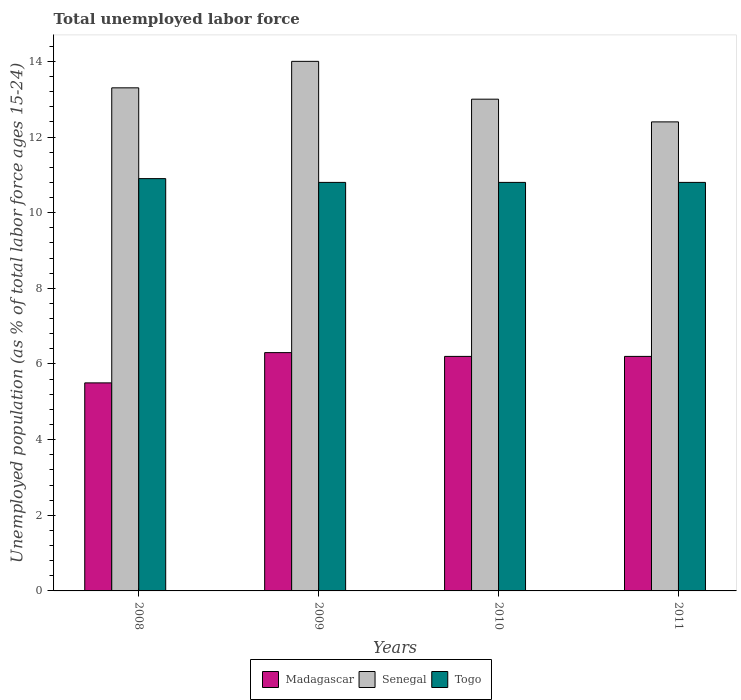How many groups of bars are there?
Keep it short and to the point. 4. Are the number of bars per tick equal to the number of legend labels?
Provide a short and direct response. Yes. Are the number of bars on each tick of the X-axis equal?
Provide a short and direct response. Yes. How many bars are there on the 2nd tick from the left?
Offer a very short reply. 3. How many bars are there on the 3rd tick from the right?
Your answer should be very brief. 3. What is the label of the 2nd group of bars from the left?
Make the answer very short. 2009. In how many cases, is the number of bars for a given year not equal to the number of legend labels?
Offer a terse response. 0. Across all years, what is the maximum percentage of unemployed population in in Madagascar?
Provide a succinct answer. 6.3. Across all years, what is the minimum percentage of unemployed population in in Senegal?
Your answer should be very brief. 12.4. In which year was the percentage of unemployed population in in Togo maximum?
Offer a terse response. 2008. In which year was the percentage of unemployed population in in Madagascar minimum?
Offer a very short reply. 2008. What is the total percentage of unemployed population in in Madagascar in the graph?
Provide a short and direct response. 24.2. What is the difference between the percentage of unemployed population in in Senegal in 2010 and that in 2011?
Your response must be concise. 0.6. What is the difference between the percentage of unemployed population in in Senegal in 2011 and the percentage of unemployed population in in Madagascar in 2009?
Make the answer very short. 6.1. What is the average percentage of unemployed population in in Senegal per year?
Make the answer very short. 13.17. In the year 2008, what is the difference between the percentage of unemployed population in in Madagascar and percentage of unemployed population in in Senegal?
Provide a short and direct response. -7.8. In how many years, is the percentage of unemployed population in in Togo greater than 4 %?
Your answer should be compact. 4. What is the ratio of the percentage of unemployed population in in Madagascar in 2009 to that in 2010?
Provide a short and direct response. 1.02. What is the difference between the highest and the second highest percentage of unemployed population in in Togo?
Your answer should be compact. 0.1. What is the difference between the highest and the lowest percentage of unemployed population in in Madagascar?
Offer a terse response. 0.8. What does the 3rd bar from the left in 2008 represents?
Your response must be concise. Togo. What does the 1st bar from the right in 2009 represents?
Give a very brief answer. Togo. How many bars are there?
Your answer should be compact. 12. Are all the bars in the graph horizontal?
Provide a succinct answer. No. How many years are there in the graph?
Offer a terse response. 4. What is the difference between two consecutive major ticks on the Y-axis?
Ensure brevity in your answer.  2. How are the legend labels stacked?
Your answer should be very brief. Horizontal. What is the title of the graph?
Your answer should be very brief. Total unemployed labor force. Does "Luxembourg" appear as one of the legend labels in the graph?
Provide a short and direct response. No. What is the label or title of the Y-axis?
Your response must be concise. Unemployed population (as % of total labor force ages 15-24). What is the Unemployed population (as % of total labor force ages 15-24) of Madagascar in 2008?
Your answer should be very brief. 5.5. What is the Unemployed population (as % of total labor force ages 15-24) of Senegal in 2008?
Provide a short and direct response. 13.3. What is the Unemployed population (as % of total labor force ages 15-24) of Togo in 2008?
Offer a very short reply. 10.9. What is the Unemployed population (as % of total labor force ages 15-24) of Madagascar in 2009?
Make the answer very short. 6.3. What is the Unemployed population (as % of total labor force ages 15-24) of Senegal in 2009?
Keep it short and to the point. 14. What is the Unemployed population (as % of total labor force ages 15-24) in Togo in 2009?
Your answer should be very brief. 10.8. What is the Unemployed population (as % of total labor force ages 15-24) in Madagascar in 2010?
Keep it short and to the point. 6.2. What is the Unemployed population (as % of total labor force ages 15-24) in Togo in 2010?
Make the answer very short. 10.8. What is the Unemployed population (as % of total labor force ages 15-24) in Madagascar in 2011?
Offer a very short reply. 6.2. What is the Unemployed population (as % of total labor force ages 15-24) of Senegal in 2011?
Your answer should be compact. 12.4. What is the Unemployed population (as % of total labor force ages 15-24) of Togo in 2011?
Your answer should be compact. 10.8. Across all years, what is the maximum Unemployed population (as % of total labor force ages 15-24) of Madagascar?
Keep it short and to the point. 6.3. Across all years, what is the maximum Unemployed population (as % of total labor force ages 15-24) of Senegal?
Offer a terse response. 14. Across all years, what is the maximum Unemployed population (as % of total labor force ages 15-24) in Togo?
Offer a very short reply. 10.9. Across all years, what is the minimum Unemployed population (as % of total labor force ages 15-24) of Madagascar?
Give a very brief answer. 5.5. Across all years, what is the minimum Unemployed population (as % of total labor force ages 15-24) in Senegal?
Keep it short and to the point. 12.4. Across all years, what is the minimum Unemployed population (as % of total labor force ages 15-24) in Togo?
Provide a succinct answer. 10.8. What is the total Unemployed population (as % of total labor force ages 15-24) in Madagascar in the graph?
Your answer should be compact. 24.2. What is the total Unemployed population (as % of total labor force ages 15-24) of Senegal in the graph?
Provide a short and direct response. 52.7. What is the total Unemployed population (as % of total labor force ages 15-24) in Togo in the graph?
Keep it short and to the point. 43.3. What is the difference between the Unemployed population (as % of total labor force ages 15-24) in Madagascar in 2008 and that in 2009?
Provide a short and direct response. -0.8. What is the difference between the Unemployed population (as % of total labor force ages 15-24) in Togo in 2008 and that in 2009?
Provide a succinct answer. 0.1. What is the difference between the Unemployed population (as % of total labor force ages 15-24) in Madagascar in 2008 and that in 2010?
Keep it short and to the point. -0.7. What is the difference between the Unemployed population (as % of total labor force ages 15-24) of Senegal in 2008 and that in 2010?
Provide a succinct answer. 0.3. What is the difference between the Unemployed population (as % of total labor force ages 15-24) in Togo in 2008 and that in 2010?
Your response must be concise. 0.1. What is the difference between the Unemployed population (as % of total labor force ages 15-24) of Madagascar in 2008 and that in 2011?
Provide a short and direct response. -0.7. What is the difference between the Unemployed population (as % of total labor force ages 15-24) in Senegal in 2008 and that in 2011?
Offer a very short reply. 0.9. What is the difference between the Unemployed population (as % of total labor force ages 15-24) in Togo in 2008 and that in 2011?
Make the answer very short. 0.1. What is the difference between the Unemployed population (as % of total labor force ages 15-24) of Togo in 2009 and that in 2010?
Your answer should be compact. 0. What is the difference between the Unemployed population (as % of total labor force ages 15-24) of Madagascar in 2009 and that in 2011?
Make the answer very short. 0.1. What is the difference between the Unemployed population (as % of total labor force ages 15-24) in Senegal in 2009 and that in 2011?
Your answer should be compact. 1.6. What is the difference between the Unemployed population (as % of total labor force ages 15-24) of Madagascar in 2010 and that in 2011?
Keep it short and to the point. 0. What is the difference between the Unemployed population (as % of total labor force ages 15-24) in Senegal in 2010 and that in 2011?
Your answer should be compact. 0.6. What is the difference between the Unemployed population (as % of total labor force ages 15-24) of Togo in 2010 and that in 2011?
Provide a short and direct response. 0. What is the difference between the Unemployed population (as % of total labor force ages 15-24) in Madagascar in 2008 and the Unemployed population (as % of total labor force ages 15-24) in Senegal in 2009?
Your answer should be compact. -8.5. What is the difference between the Unemployed population (as % of total labor force ages 15-24) in Madagascar in 2008 and the Unemployed population (as % of total labor force ages 15-24) in Togo in 2009?
Provide a succinct answer. -5.3. What is the difference between the Unemployed population (as % of total labor force ages 15-24) in Madagascar in 2008 and the Unemployed population (as % of total labor force ages 15-24) in Senegal in 2010?
Offer a terse response. -7.5. What is the difference between the Unemployed population (as % of total labor force ages 15-24) of Madagascar in 2008 and the Unemployed population (as % of total labor force ages 15-24) of Togo in 2010?
Provide a succinct answer. -5.3. What is the difference between the Unemployed population (as % of total labor force ages 15-24) of Madagascar in 2008 and the Unemployed population (as % of total labor force ages 15-24) of Togo in 2011?
Keep it short and to the point. -5.3. What is the difference between the Unemployed population (as % of total labor force ages 15-24) of Madagascar in 2009 and the Unemployed population (as % of total labor force ages 15-24) of Togo in 2010?
Your answer should be very brief. -4.5. What is the difference between the Unemployed population (as % of total labor force ages 15-24) in Senegal in 2009 and the Unemployed population (as % of total labor force ages 15-24) in Togo in 2011?
Offer a very short reply. 3.2. What is the difference between the Unemployed population (as % of total labor force ages 15-24) in Madagascar in 2010 and the Unemployed population (as % of total labor force ages 15-24) in Senegal in 2011?
Your answer should be very brief. -6.2. What is the difference between the Unemployed population (as % of total labor force ages 15-24) in Madagascar in 2010 and the Unemployed population (as % of total labor force ages 15-24) in Togo in 2011?
Your answer should be very brief. -4.6. What is the average Unemployed population (as % of total labor force ages 15-24) in Madagascar per year?
Your answer should be very brief. 6.05. What is the average Unemployed population (as % of total labor force ages 15-24) in Senegal per year?
Give a very brief answer. 13.18. What is the average Unemployed population (as % of total labor force ages 15-24) of Togo per year?
Offer a very short reply. 10.82. In the year 2008, what is the difference between the Unemployed population (as % of total labor force ages 15-24) in Madagascar and Unemployed population (as % of total labor force ages 15-24) in Senegal?
Offer a very short reply. -7.8. In the year 2008, what is the difference between the Unemployed population (as % of total labor force ages 15-24) of Senegal and Unemployed population (as % of total labor force ages 15-24) of Togo?
Give a very brief answer. 2.4. In the year 2009, what is the difference between the Unemployed population (as % of total labor force ages 15-24) of Madagascar and Unemployed population (as % of total labor force ages 15-24) of Senegal?
Offer a very short reply. -7.7. In the year 2009, what is the difference between the Unemployed population (as % of total labor force ages 15-24) in Senegal and Unemployed population (as % of total labor force ages 15-24) in Togo?
Offer a terse response. 3.2. In the year 2010, what is the difference between the Unemployed population (as % of total labor force ages 15-24) in Madagascar and Unemployed population (as % of total labor force ages 15-24) in Senegal?
Keep it short and to the point. -6.8. In the year 2011, what is the difference between the Unemployed population (as % of total labor force ages 15-24) in Senegal and Unemployed population (as % of total labor force ages 15-24) in Togo?
Give a very brief answer. 1.6. What is the ratio of the Unemployed population (as % of total labor force ages 15-24) in Madagascar in 2008 to that in 2009?
Your answer should be very brief. 0.87. What is the ratio of the Unemployed population (as % of total labor force ages 15-24) in Togo in 2008 to that in 2009?
Keep it short and to the point. 1.01. What is the ratio of the Unemployed population (as % of total labor force ages 15-24) of Madagascar in 2008 to that in 2010?
Keep it short and to the point. 0.89. What is the ratio of the Unemployed population (as % of total labor force ages 15-24) in Senegal in 2008 to that in 2010?
Make the answer very short. 1.02. What is the ratio of the Unemployed population (as % of total labor force ages 15-24) in Togo in 2008 to that in 2010?
Keep it short and to the point. 1.01. What is the ratio of the Unemployed population (as % of total labor force ages 15-24) in Madagascar in 2008 to that in 2011?
Your answer should be very brief. 0.89. What is the ratio of the Unemployed population (as % of total labor force ages 15-24) in Senegal in 2008 to that in 2011?
Offer a terse response. 1.07. What is the ratio of the Unemployed population (as % of total labor force ages 15-24) in Togo in 2008 to that in 2011?
Your answer should be very brief. 1.01. What is the ratio of the Unemployed population (as % of total labor force ages 15-24) in Madagascar in 2009 to that in 2010?
Give a very brief answer. 1.02. What is the ratio of the Unemployed population (as % of total labor force ages 15-24) of Senegal in 2009 to that in 2010?
Provide a short and direct response. 1.08. What is the ratio of the Unemployed population (as % of total labor force ages 15-24) in Togo in 2009 to that in 2010?
Keep it short and to the point. 1. What is the ratio of the Unemployed population (as % of total labor force ages 15-24) in Madagascar in 2009 to that in 2011?
Give a very brief answer. 1.02. What is the ratio of the Unemployed population (as % of total labor force ages 15-24) in Senegal in 2009 to that in 2011?
Provide a short and direct response. 1.13. What is the ratio of the Unemployed population (as % of total labor force ages 15-24) of Togo in 2009 to that in 2011?
Make the answer very short. 1. What is the ratio of the Unemployed population (as % of total labor force ages 15-24) in Madagascar in 2010 to that in 2011?
Offer a terse response. 1. What is the ratio of the Unemployed population (as % of total labor force ages 15-24) of Senegal in 2010 to that in 2011?
Keep it short and to the point. 1.05. What is the ratio of the Unemployed population (as % of total labor force ages 15-24) of Togo in 2010 to that in 2011?
Provide a short and direct response. 1. What is the difference between the highest and the second highest Unemployed population (as % of total labor force ages 15-24) in Madagascar?
Offer a terse response. 0.1. What is the difference between the highest and the second highest Unemployed population (as % of total labor force ages 15-24) of Senegal?
Ensure brevity in your answer.  0.7. What is the difference between the highest and the lowest Unemployed population (as % of total labor force ages 15-24) in Madagascar?
Provide a short and direct response. 0.8. What is the difference between the highest and the lowest Unemployed population (as % of total labor force ages 15-24) in Togo?
Provide a short and direct response. 0.1. 